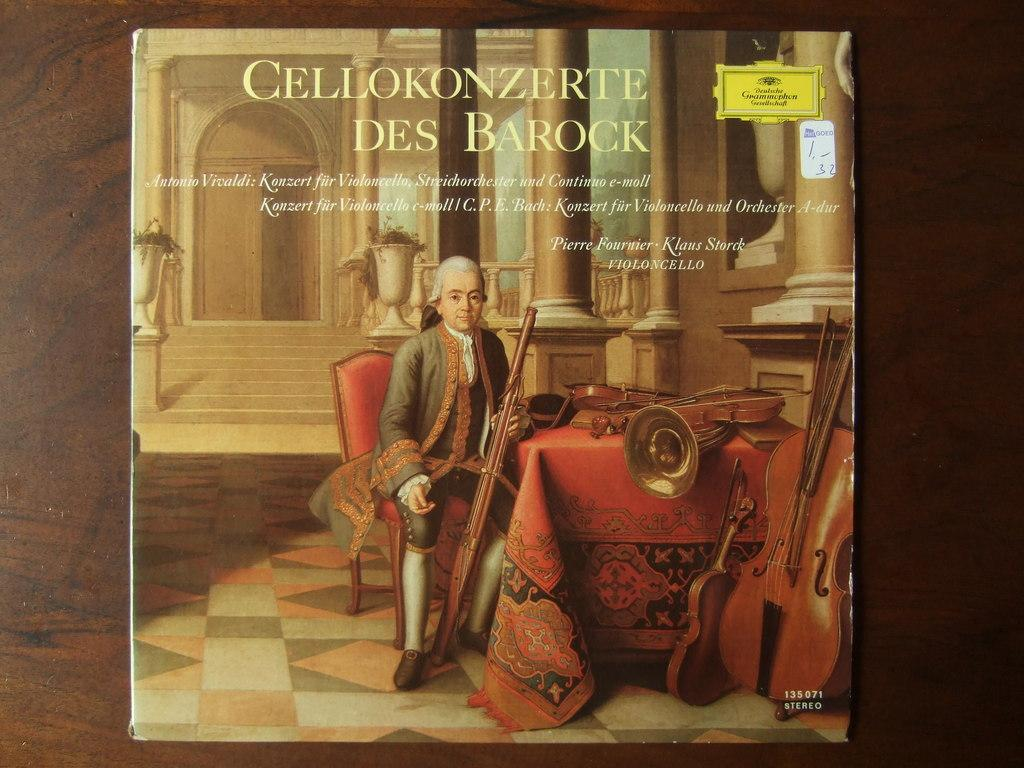<image>
Render a clear and concise summary of the photo. A record case with the tittle Cellokonzerte Des Barock on the cover. 